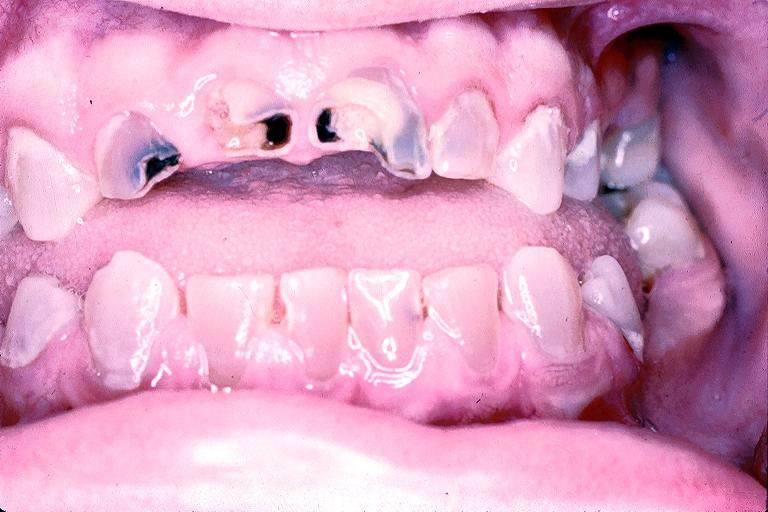where is this?
Answer the question using a single word or phrase. Oral 